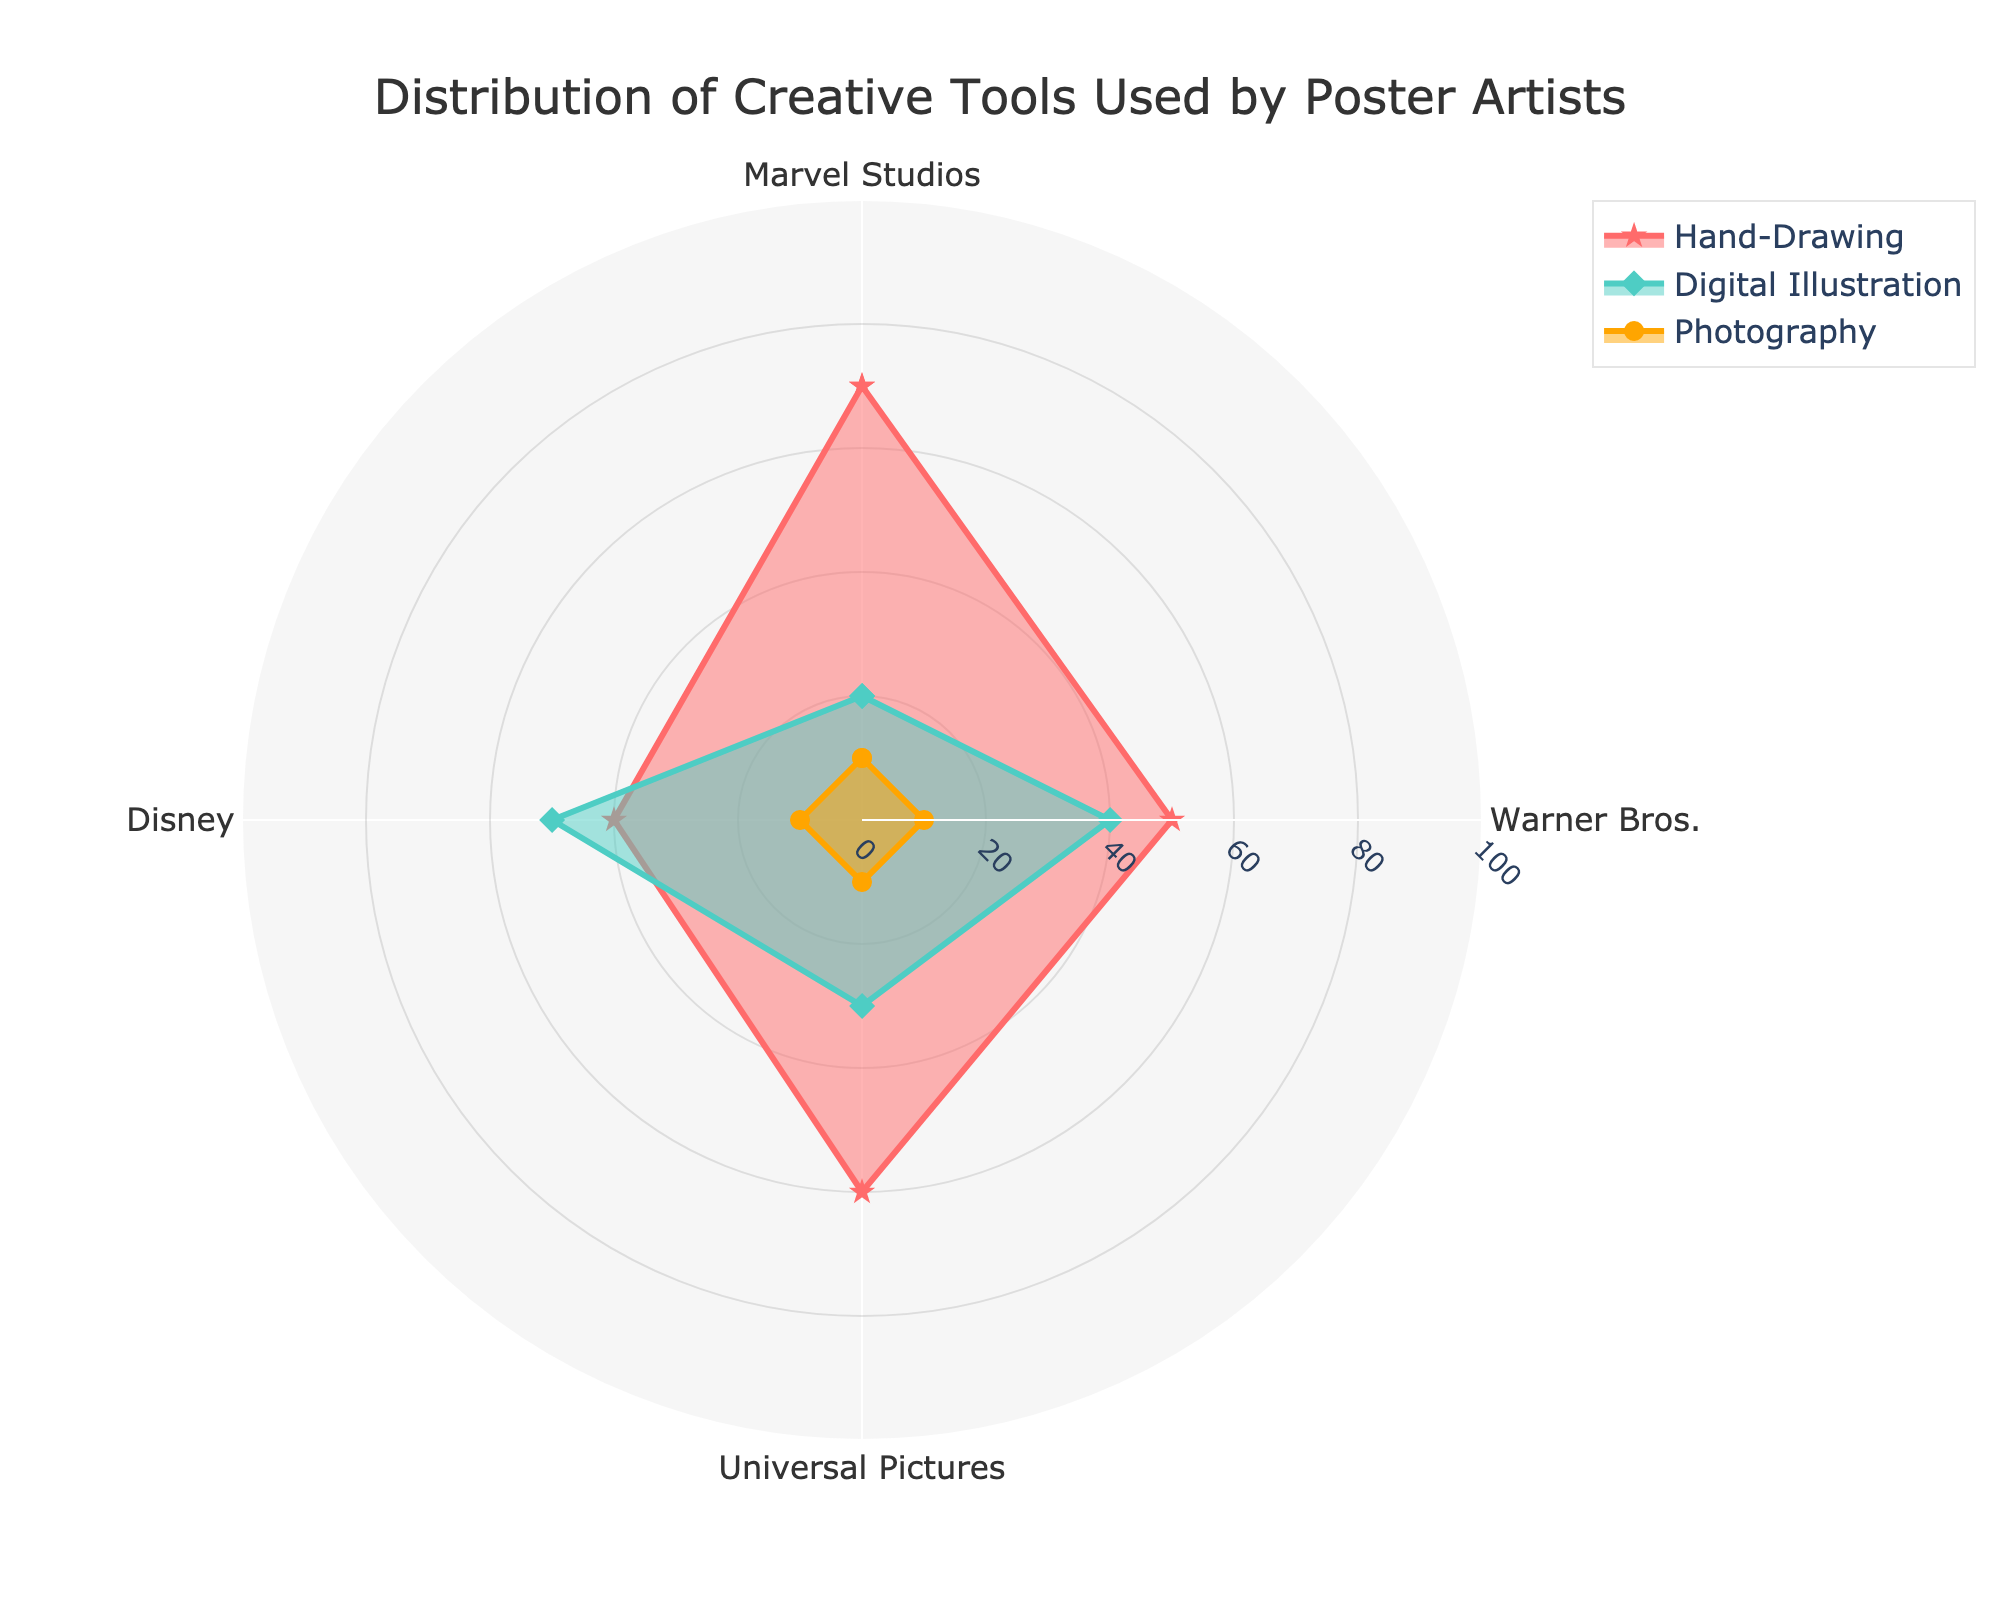what is the title of the figure? The title is usually located at the top of the figure and helps in understanding the main subject of the plot. Upon examining the top part of the radar chart, you will see the title "Distribution of Creative Tools Used by Poster Artists".
Answer: Distribution of Creative Tools Used by Poster Artists How many categories are shown in the radar chart? By looking at the number of axis labels or categories in the radar chart, you can see that the data is grouped into different categories such as Marvel Studios, Warner Bros., Universal Pictures, and Disney, totaling 4 categories.
Answer: 4 Which studio uses Digital Illustration the most? To find this, look for the highest point in the "Digital Illustration" trace. The data points for "Digital Illustration" for each studio are visible on the radar chart, and you can observe that Disney has the highest value of 50.
Answer: Disney What is the average percentage of Hand-Drawing across all studios? Sum the Hand-Drawing percentages for all studios: 70 (Marvel Studios) + 50 (Warner Bros.) + 60 (Universal Pictures) + 40 (Disney) = 220. Then, divide this total by the number of categories (4) to find the average: 220 / 4 = 55.
Answer: 55 Which studio has an equal distribution for Hand-Drawing and Digital Illustration? To determine this, look for a studio where the two values for Hand-Drawing and Digital Illustration are the same. In the radar chart, the data points indicate that no studio has equal values for these two categories.
Answer: None For which tool is there no variation in usage across all studios? To find this, identify a tool category where all studios have the same value. In this radar chart, checking the Photography category shows that all studios have a value of 10.
Answer: Photography How much less is Hand-Drawing used by Disney compared to Marvel Studios? Subtract Disney's Hand-Drawing value from Marvel Studios' Hand-Drawing value: 70 (Marvel Studios) - 40 (Disney) = 30.
Answer: 30 Which studio has the second highest usage of Hand-Drawing? The Hand-Drawing values for each studio are: Marvel Studios (70), Warner Bros. (50), Universal Pictures (60), Disney (40). The second highest value is 60, which corresponds to Universal Pictures.
Answer: Universal Pictures What is the total percentage of all tools used by Warner Bros.? Sum the values for Hand-Drawing, Digital Illustration, and Photography for Warner Bros.: 50 (Hand-Drawing) + 40 (Digital Illustration) + 10 (Photography) = 100.
Answer: 100 Which creative tool has the highest average usage? Calculate the average usage for each tool category:
Hand-Drawing: (70 + 50 + 60 + 40) / 4 = 55
Digital Illustration: (20 + 40 + 30 + 50) / 4 = 35
Photography: (10 + 10 + 10 + 10) / 4 = 10
The highest average usage is for Hand-Drawing.
Answer: Hand-Drawing 